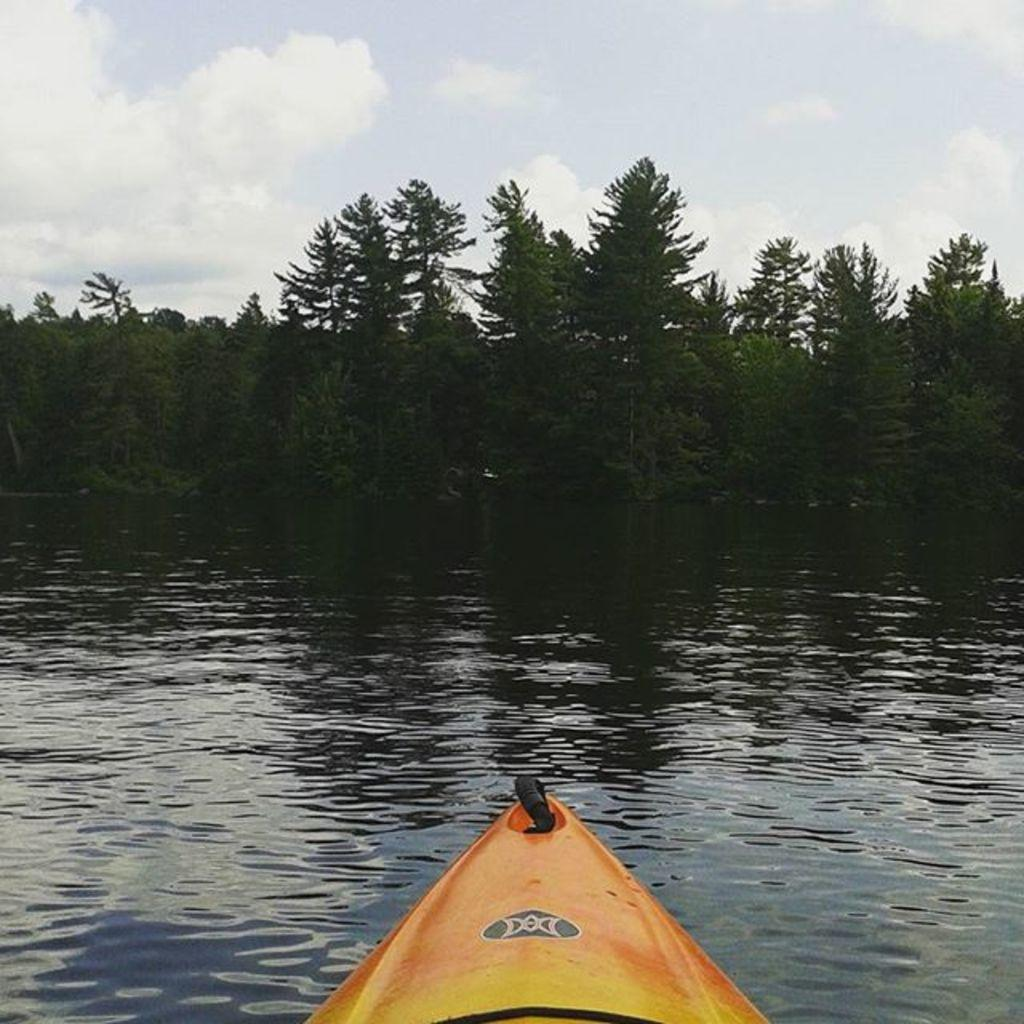What is the main subject of the image? The main subject of the image is a boat. Where is the boat located in the image? The boat is on the water. What can be seen in the background of the image? There are trees and the sky visible in the background of the image. What type of transport is visible in the frame of the image? There is no frame present in the image, and the boat is already identified as the main subject. What is the taste of the water in the image? The taste of the water cannot be determined from the image, as taste is not a visual characteristic. 